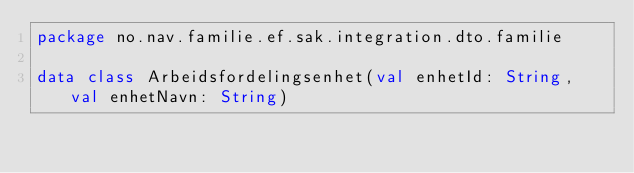<code> <loc_0><loc_0><loc_500><loc_500><_Kotlin_>package no.nav.familie.ef.sak.integration.dto.familie

data class Arbeidsfordelingsenhet(val enhetId: String, val enhetNavn: String)</code> 